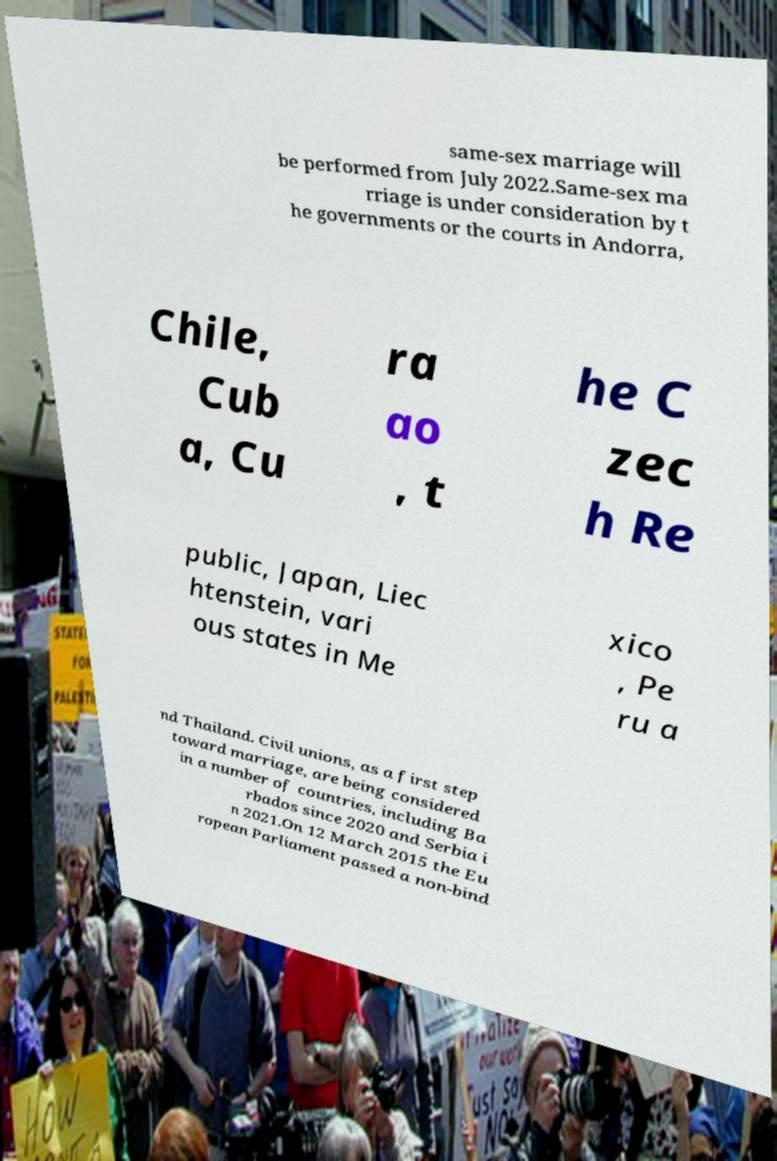Please identify and transcribe the text found in this image. same-sex marriage will be performed from July 2022.Same-sex ma rriage is under consideration by t he governments or the courts in Andorra, Chile, Cub a, Cu ra ao , t he C zec h Re public, Japan, Liec htenstein, vari ous states in Me xico , Pe ru a nd Thailand. Civil unions, as a first step toward marriage, are being considered in a number of countries, including Ba rbados since 2020 and Serbia i n 2021.On 12 March 2015 the Eu ropean Parliament passed a non-bind 